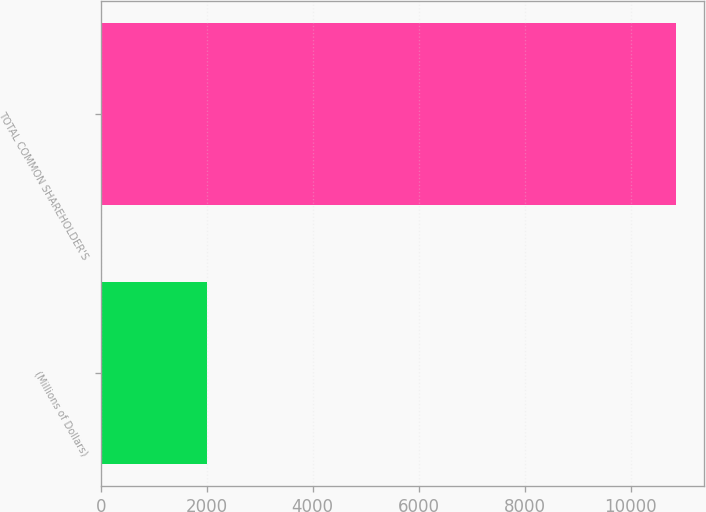<chart> <loc_0><loc_0><loc_500><loc_500><bar_chart><fcel>(Millions of Dollars)<fcel>TOTAL COMMON SHAREHOLDER'S<nl><fcel>2013<fcel>10853<nl></chart> 